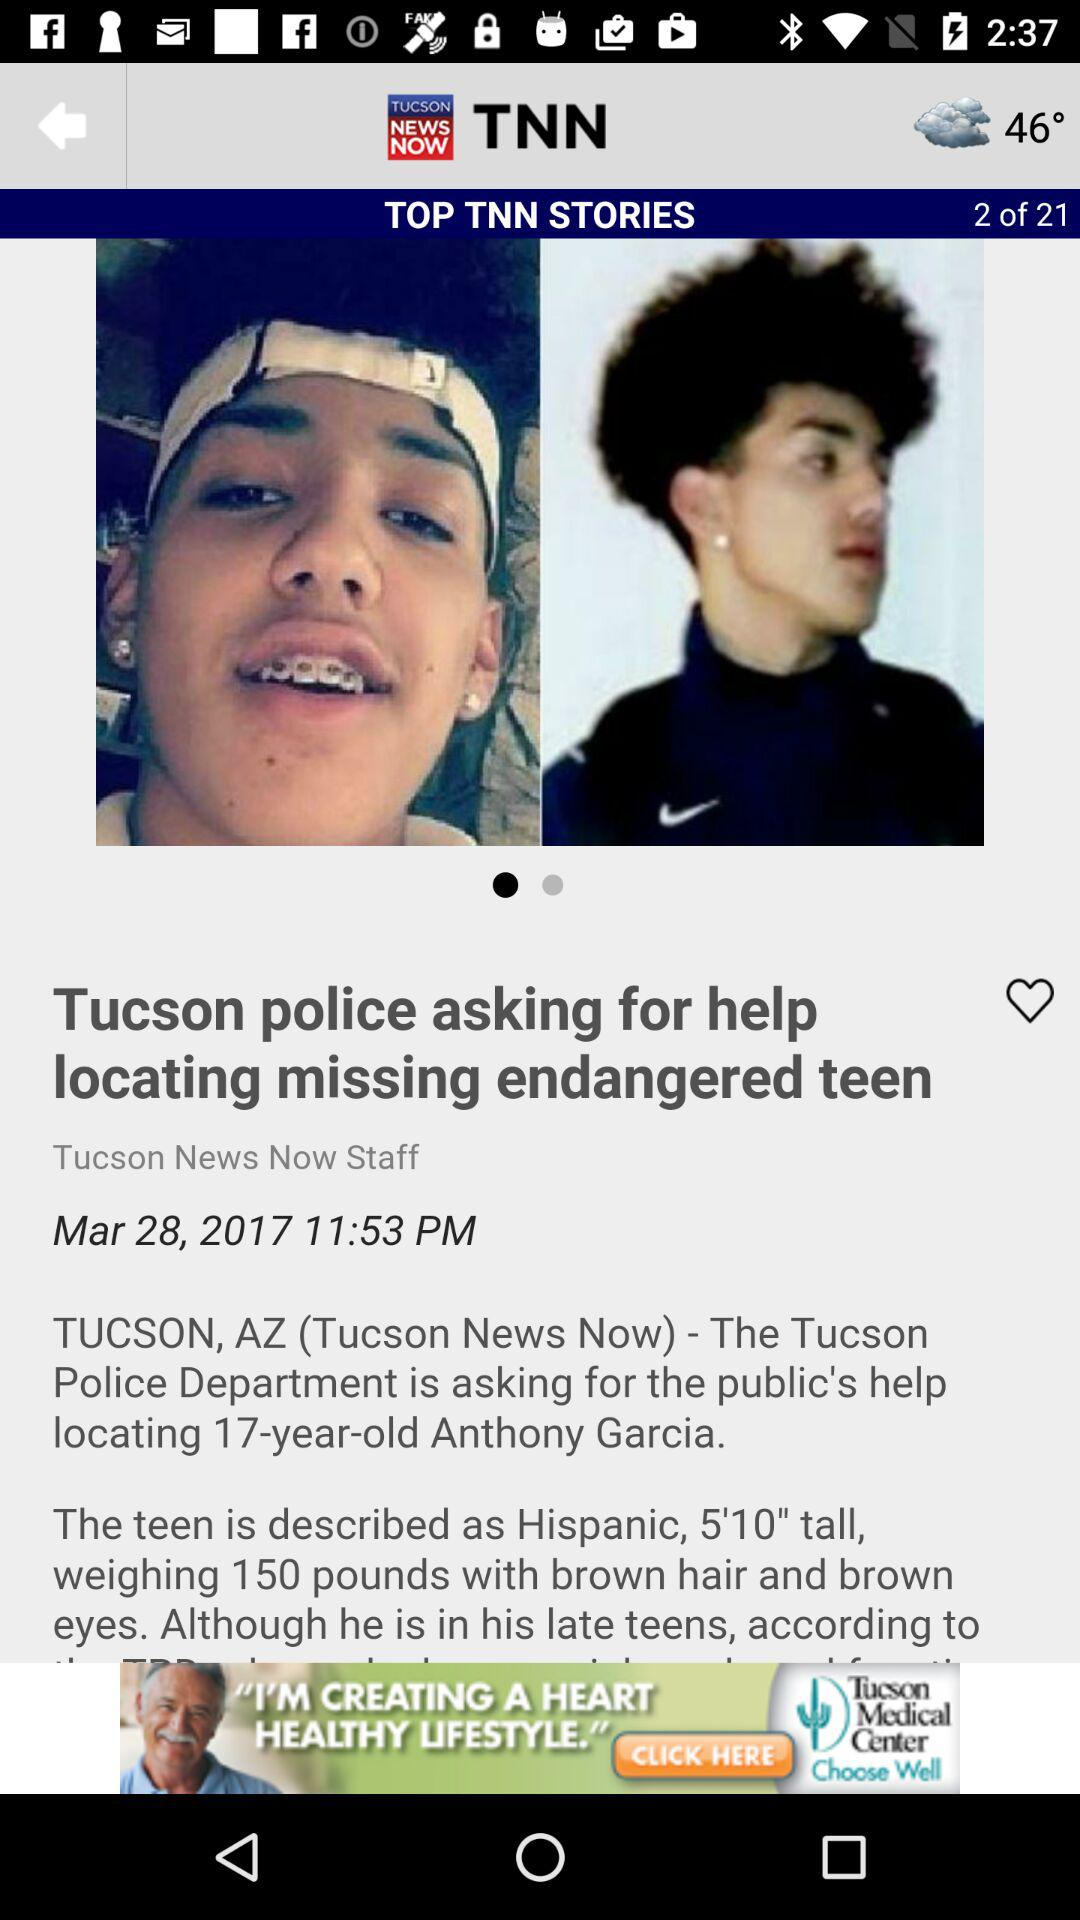Which news channels have published this article?
When the provided information is insufficient, respond with <no answer>. <no answer> 